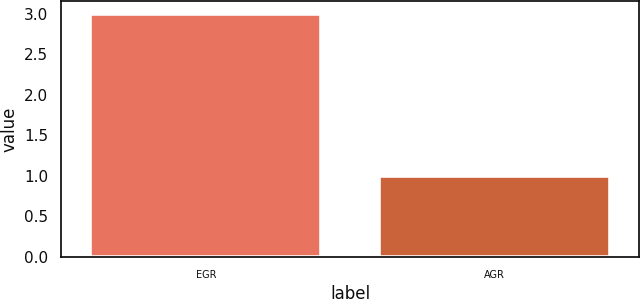<chart> <loc_0><loc_0><loc_500><loc_500><bar_chart><fcel>EGR<fcel>AGR<nl><fcel>3<fcel>1<nl></chart> 